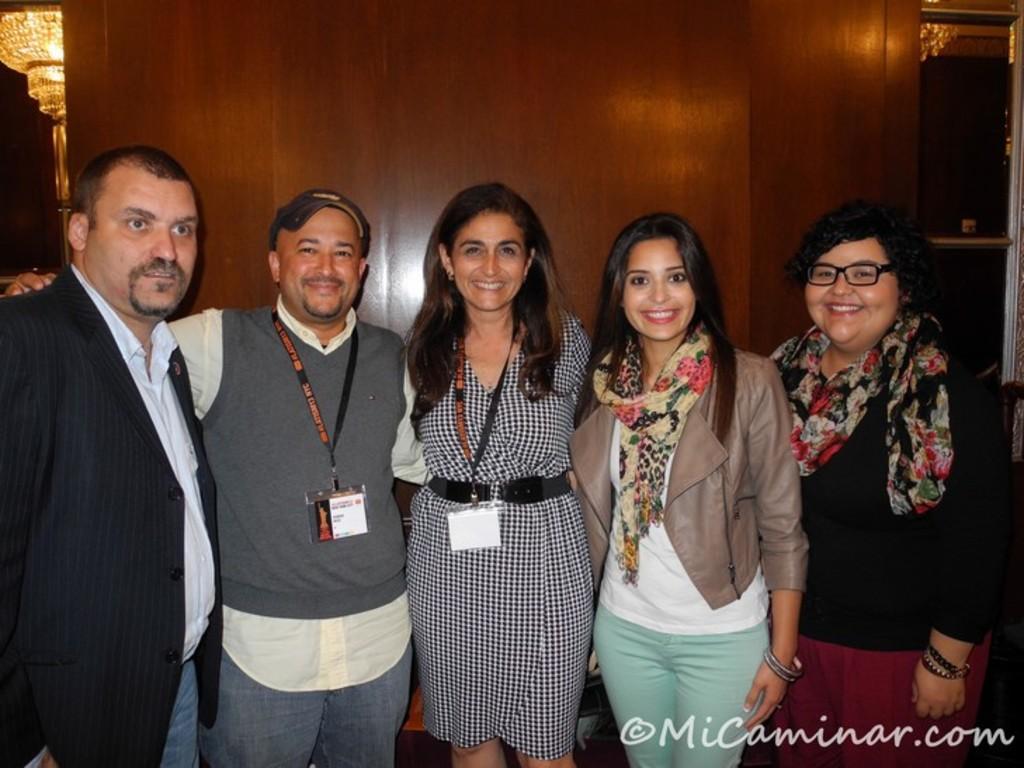Can you describe this image briefly? There is a group of people standing as we can see at the bottom of this image and there is a wooden wall in the background. There is a light in the top left corner of this image. 